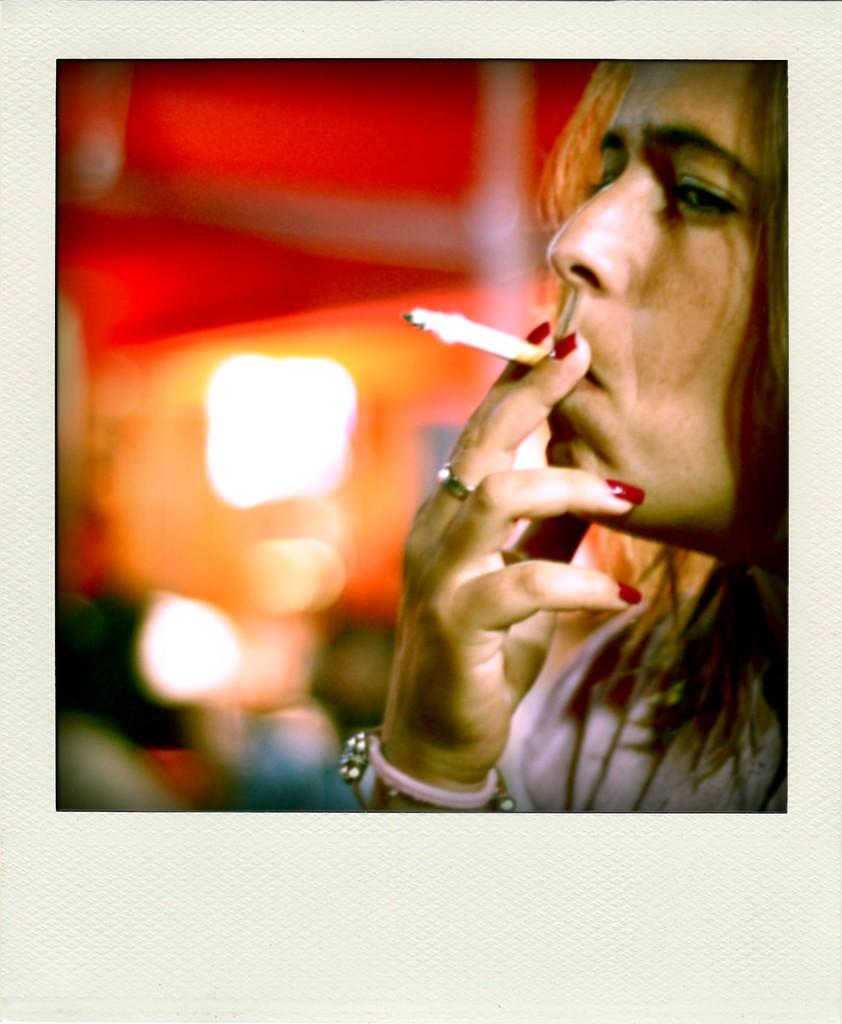Who is present in the image? There is a woman in the image. Where is the woman located in the image? The woman is towards the right side of the image. What is the woman doing in the image? The woman is smoking. What scent can be detected from the river in the image? There is no river present in the image, so no scent can be detected from it. 